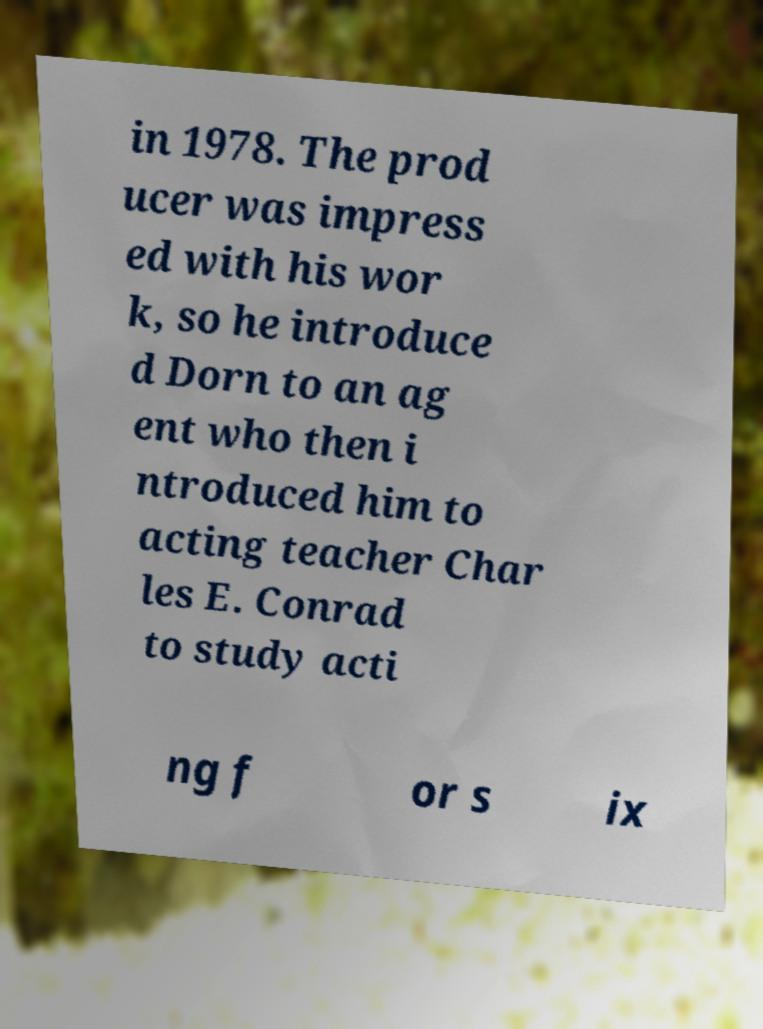There's text embedded in this image that I need extracted. Can you transcribe it verbatim? in 1978. The prod ucer was impress ed with his wor k, so he introduce d Dorn to an ag ent who then i ntroduced him to acting teacher Char les E. Conrad to study acti ng f or s ix 